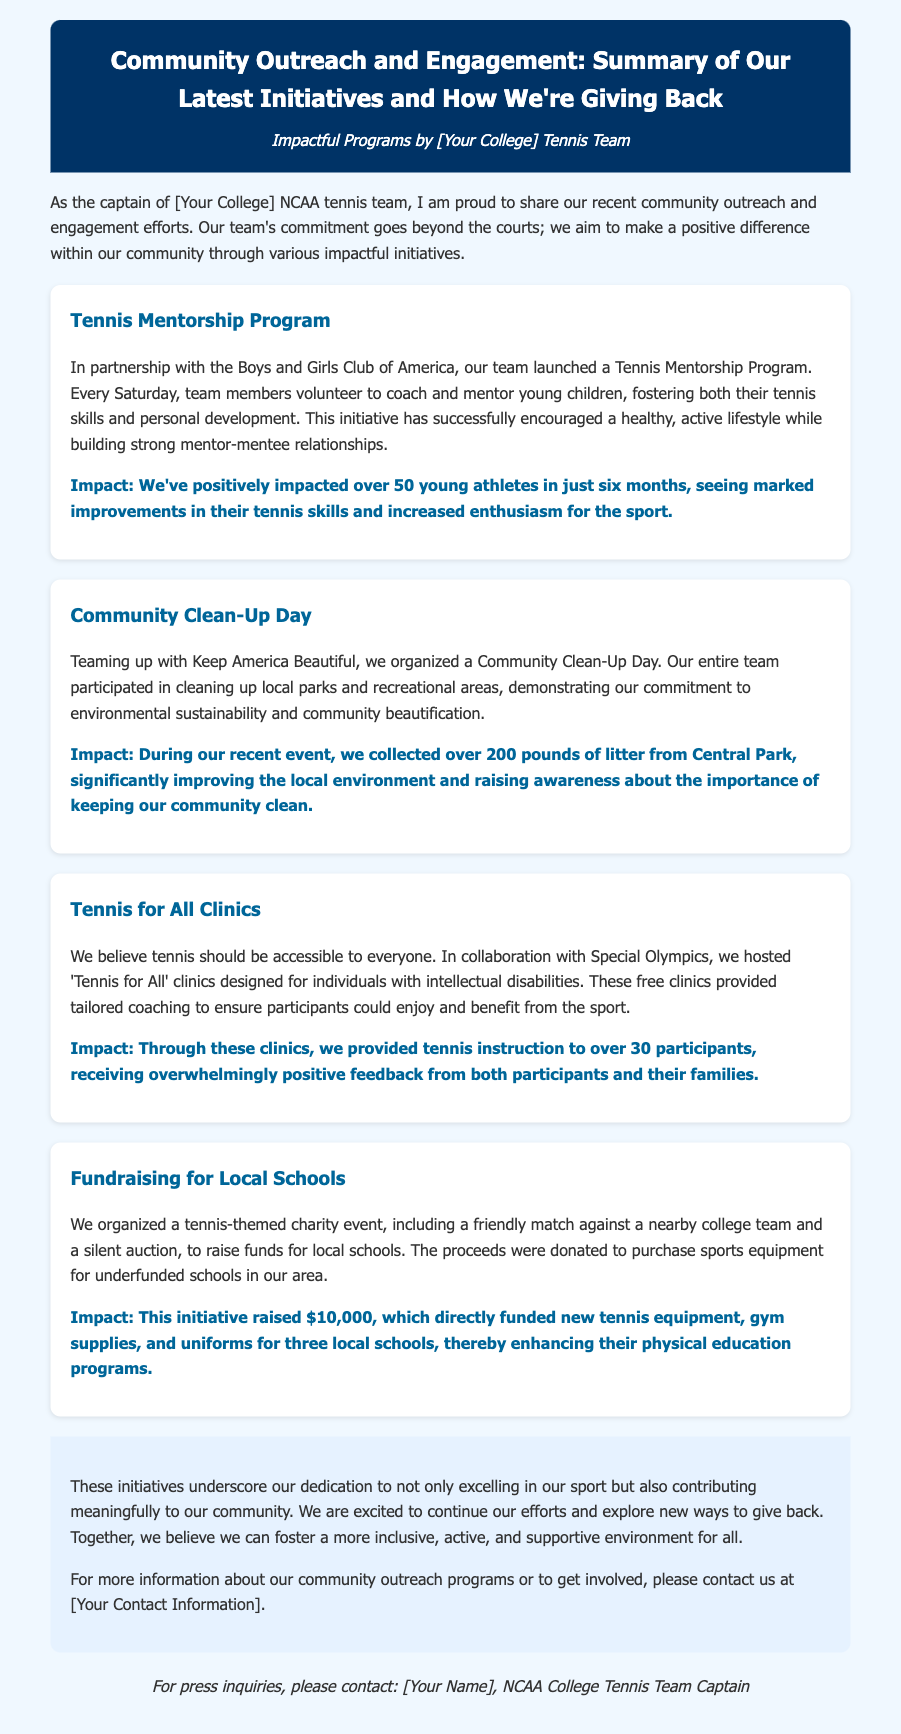What is the title of the press release? The title reflects the overall theme and purpose of the document, which is expressed clearly at the top.
Answer: Community Outreach and Engagement: Summary of Our Latest Initiatives and How We're Giving Back How many young athletes were positively impacted by the Tennis Mentorship Program? The document states the specific number of young athletes who benefited from this initiative during a set timeframe.
Answer: 50 What organization did the team partner with for the Tennis Mentorship Program? This information highlights the collaboration aspect of the initiative mentioned in the document.
Answer: Boys and Girls Club of America How much money was raised for local schools during the fundraising event? The document specifies the amount collected through the charity event focused on supporting educational resources.
Answer: $10,000 What is one of the objectives of the Tennis for All Clinics? The document describes the aims of this initiative, seeking to promote inclusion in sports.
Answer: Accessibility What was collected during the Community Clean-Up Day? The document lists what the team achieved during the clean-up initiative, which reflects their environmental commitment.
Answer: 200 pounds of litter What type of feedback was received from participants of the Tennis for All Clinics? The document mentions the nature of feedback received regarding these clinics, which indicates their success.
Answer: Overwhelmingly positive Who is the author of the press release? This question identifies the individual responsible for the information presented in the document.
Answer: [Your Name] 